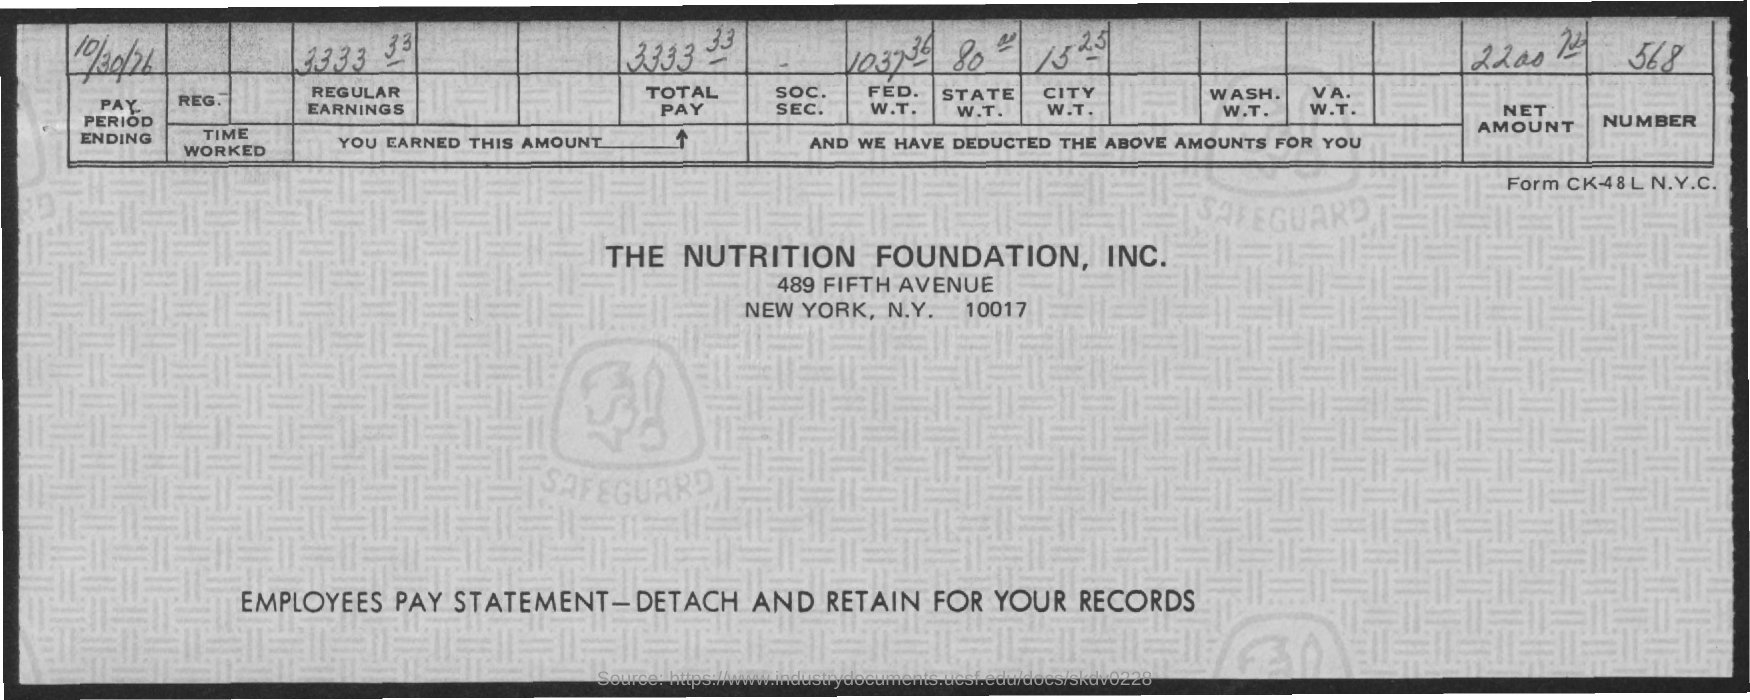List a handful of essential elements in this visual. On October 30, 1976, the pay period will end. 